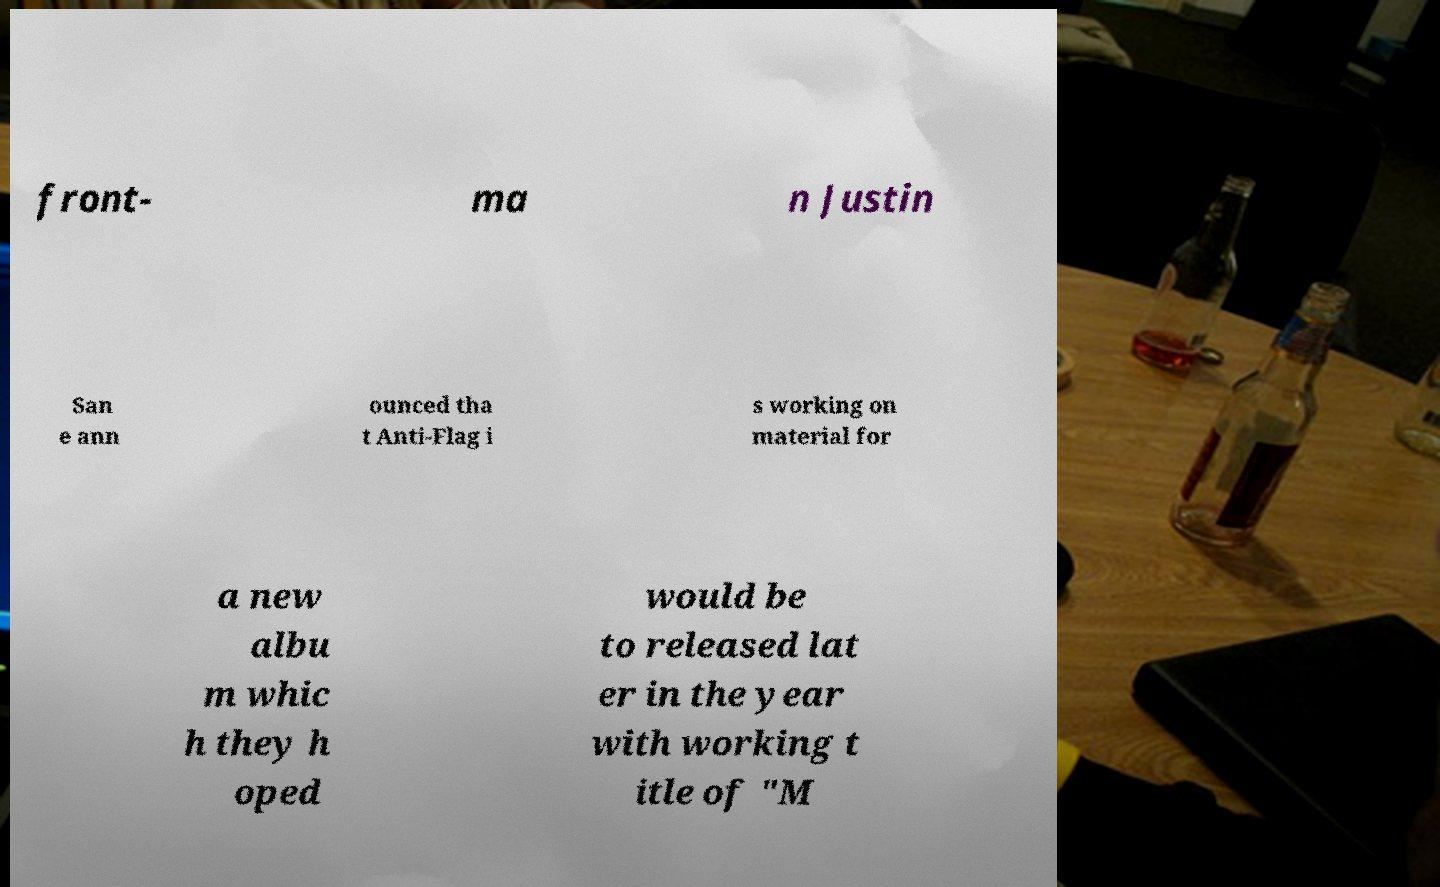For documentation purposes, I need the text within this image transcribed. Could you provide that? front- ma n Justin San e ann ounced tha t Anti-Flag i s working on material for a new albu m whic h they h oped would be to released lat er in the year with working t itle of "M 